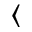Convert formula to latex. <formula><loc_0><loc_0><loc_500><loc_500>\langle</formula> 